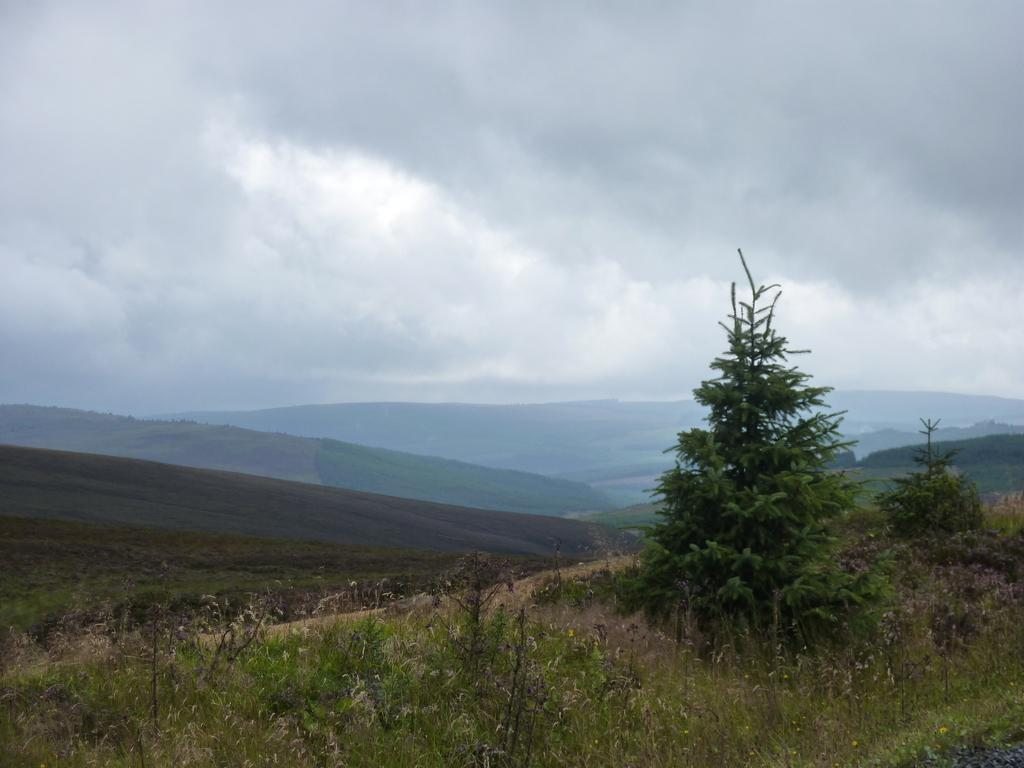What type of plant can be seen in the image? There is a tree in the image. Where is the tree located? The tree is on a grassland. What can be seen in the background of the image? There are hills visible in the background of the image. What is visible in the sky in the image? The sky is visible in the image, and clouds are present. Is the queen using a camera to swim in the image? There is no queen, camera, or swimming activity present in the image. 